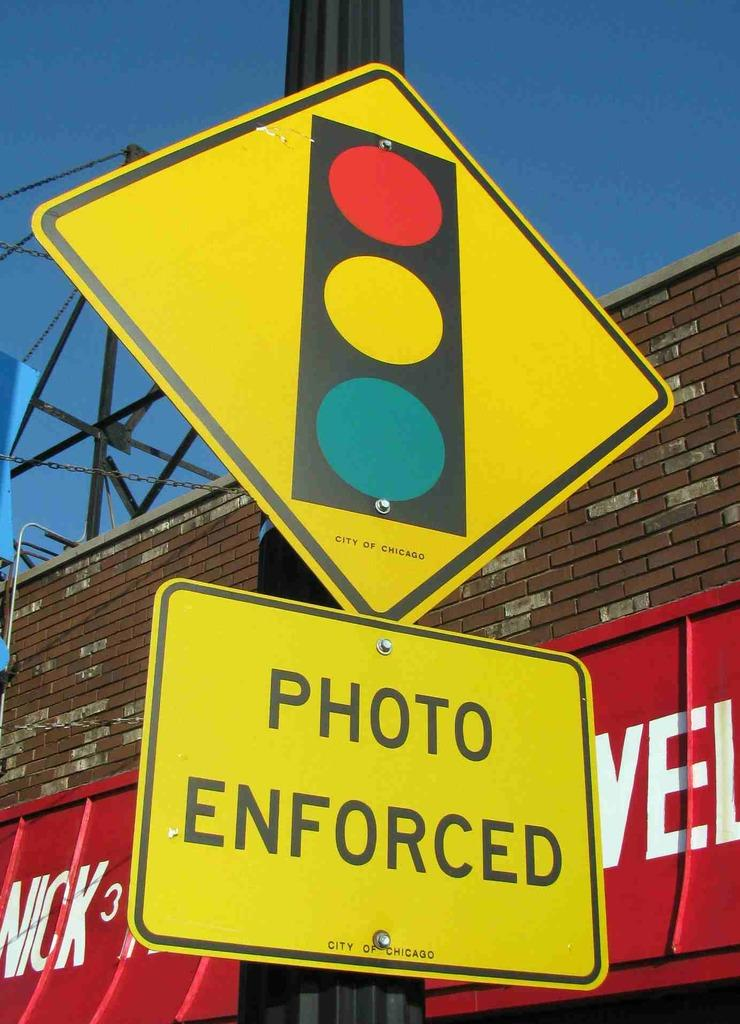<image>
Give a short and clear explanation of the subsequent image. the words photo enforced is on a sign 